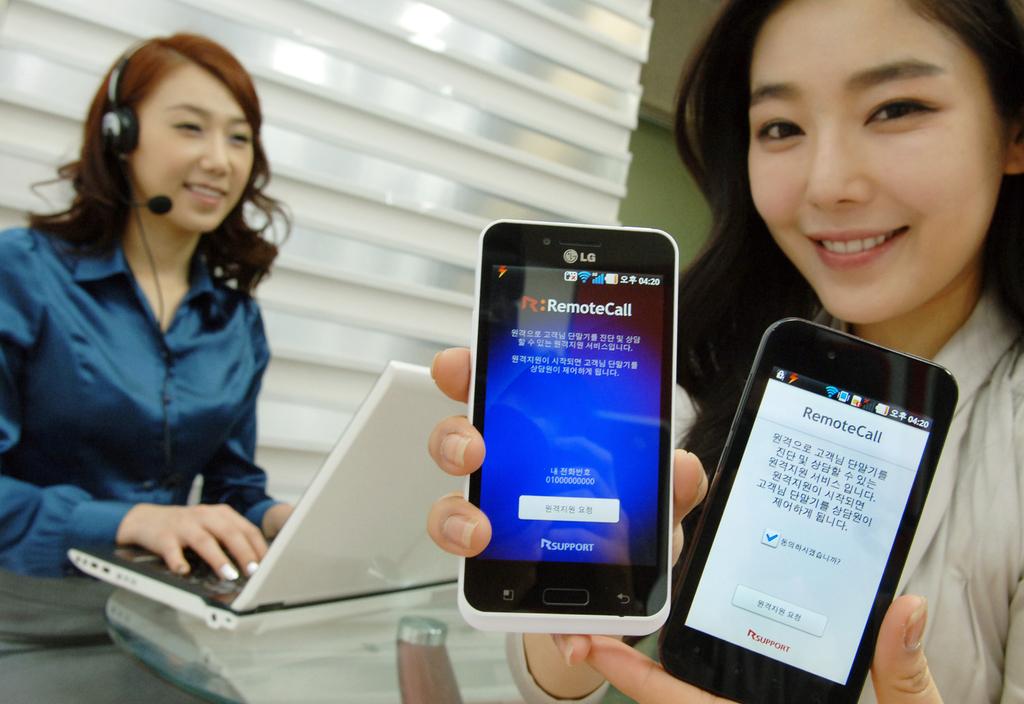What does the white text say on the red background?
Offer a very short reply. Remotecall. 